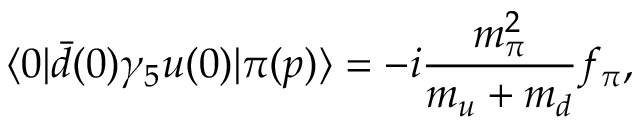Convert formula to latex. <formula><loc_0><loc_0><loc_500><loc_500>\langle 0 | \bar { d } ( 0 ) \gamma _ { 5 } u ( 0 ) | \pi ( p ) \rangle = - i \frac { m _ { \pi } ^ { 2 } } { m _ { u } + m _ { d } } f _ { \pi } ,</formula> 